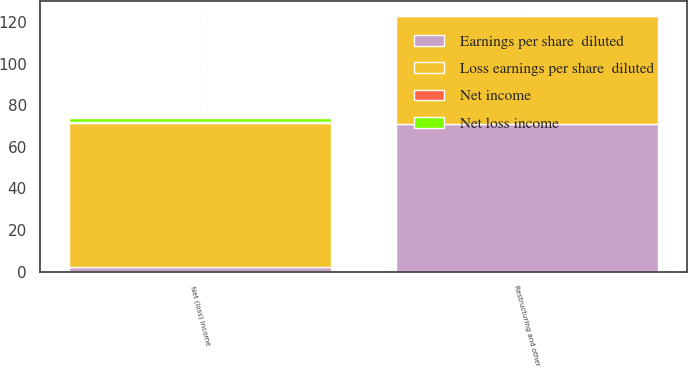Convert chart to OTSL. <chart><loc_0><loc_0><loc_500><loc_500><stacked_bar_chart><ecel><fcel>Net (loss) income<fcel>Restructuring and other<nl><fcel>Loss earnings per share  diluted<fcel>69<fcel>52<nl><fcel>Net income<fcel>0.41<fcel>0.31<nl><fcel>Earnings per share  diluted<fcel>2.29<fcel>71<nl><fcel>Net loss income<fcel>2.29<fcel>0.42<nl></chart> 